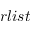Convert formula to latex. <formula><loc_0><loc_0><loc_500><loc_500>r l i s t</formula> 